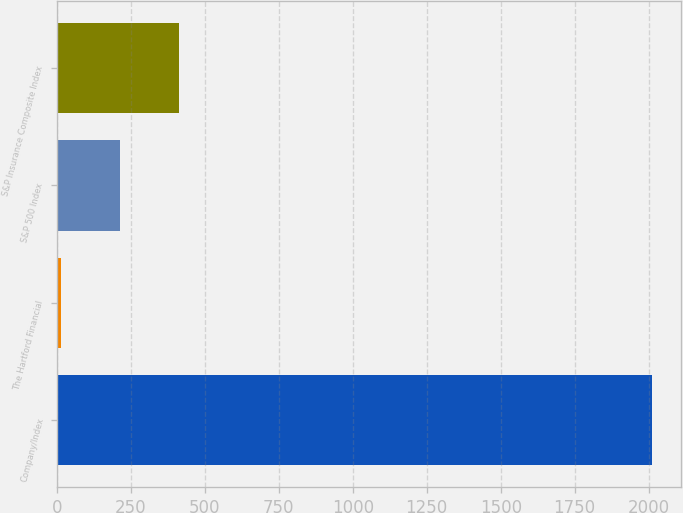Convert chart to OTSL. <chart><loc_0><loc_0><loc_500><loc_500><bar_chart><fcel>Company/Index<fcel>The Hartford Financial<fcel>S&P 500 Index<fcel>S&P Insurance Composite Index<nl><fcel>2010<fcel>14.89<fcel>214.4<fcel>413.91<nl></chart> 